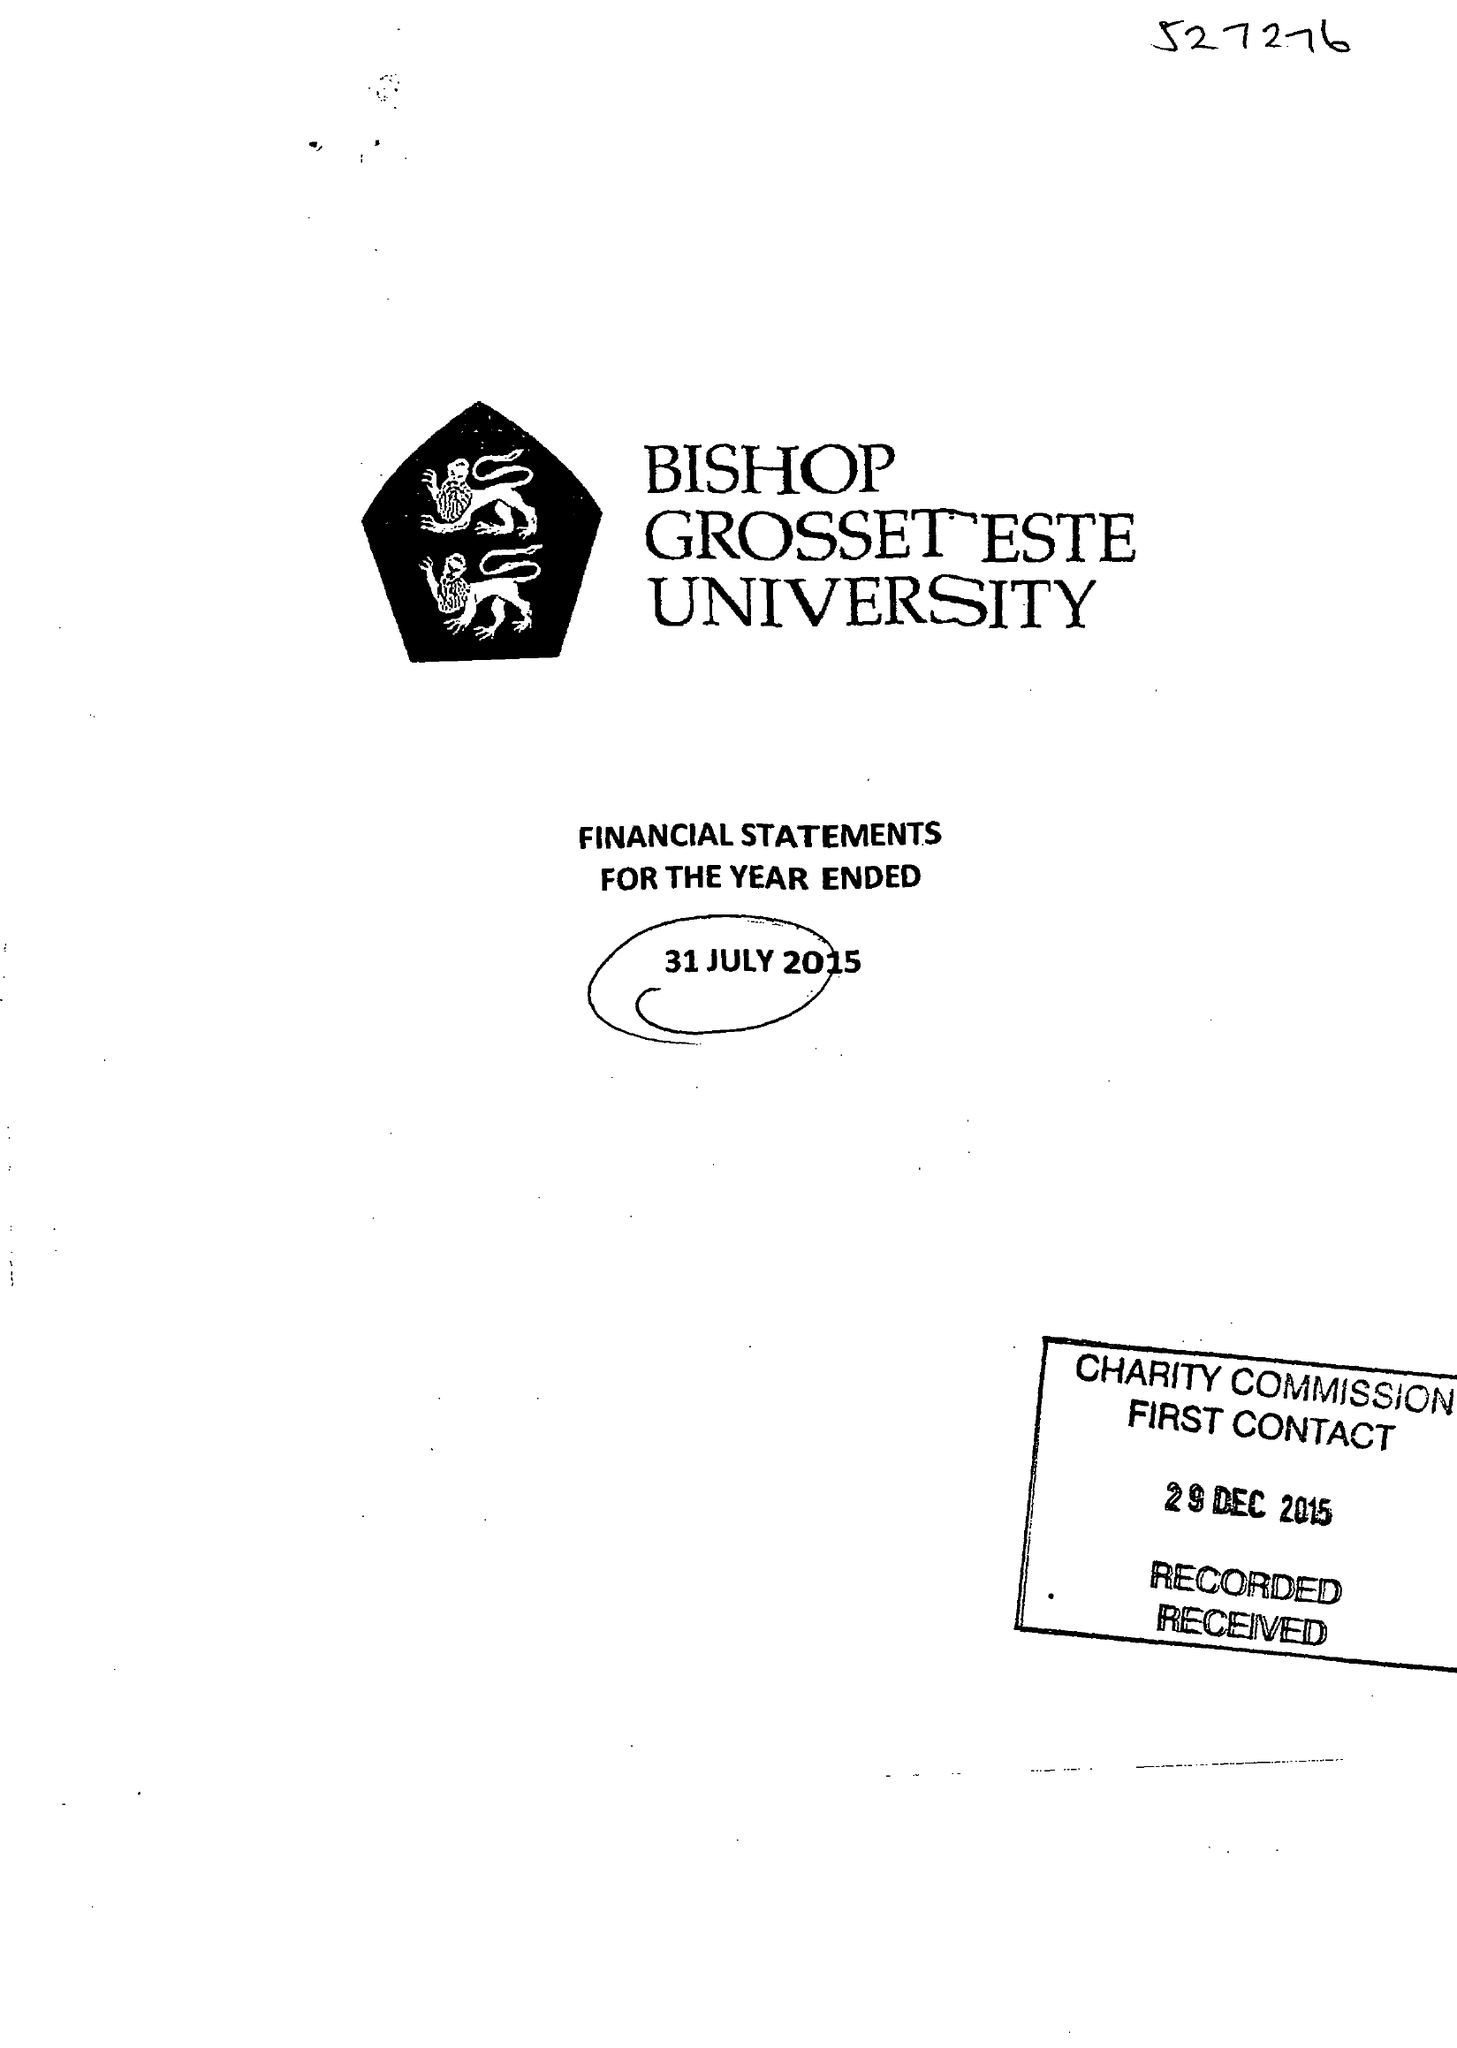What is the value for the report_date?
Answer the question using a single word or phrase. 2015-07-31 